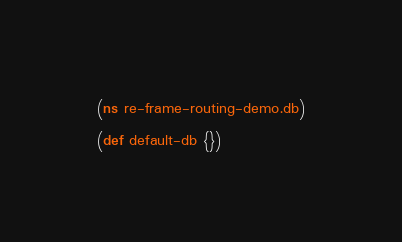Convert code to text. <code><loc_0><loc_0><loc_500><loc_500><_Clojure_>(ns re-frame-routing-demo.db)

(def default-db {})
</code> 